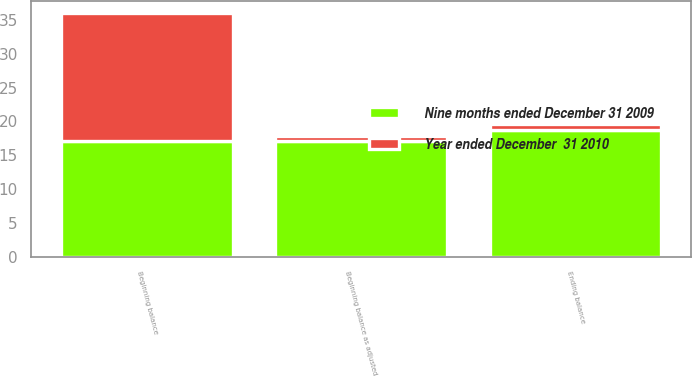Convert chart to OTSL. <chart><loc_0><loc_0><loc_500><loc_500><stacked_bar_chart><ecel><fcel>Beginning balance<fcel>Beginning balance as adjusted<fcel>Ending balance<nl><fcel>Year ended December  31 2010<fcel>18.8<fcel>0.8<fcel>0.8<nl><fcel>Nine months ended December 31 2009<fcel>17.1<fcel>17.1<fcel>18.8<nl></chart> 